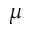Convert formula to latex. <formula><loc_0><loc_0><loc_500><loc_500>\mu</formula> 